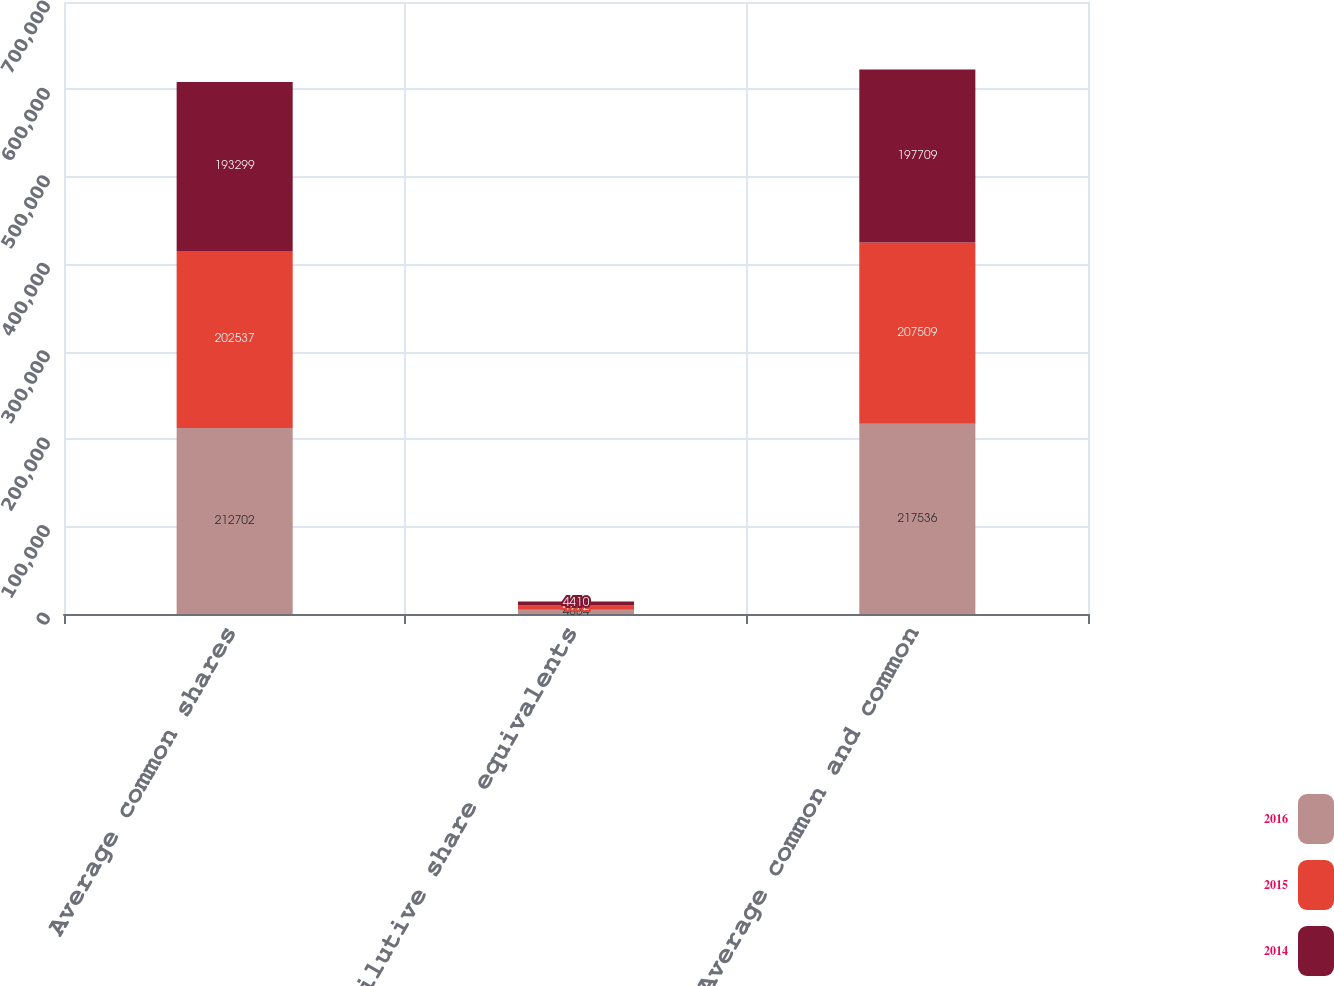Convert chart. <chart><loc_0><loc_0><loc_500><loc_500><stacked_bar_chart><ecel><fcel>Average common shares<fcel>Dilutive share equivalents<fcel>Average common and common<nl><fcel>2016<fcel>212702<fcel>4834<fcel>217536<nl><fcel>2015<fcel>202537<fcel>4972<fcel>207509<nl><fcel>2014<fcel>193299<fcel>4410<fcel>197709<nl></chart> 